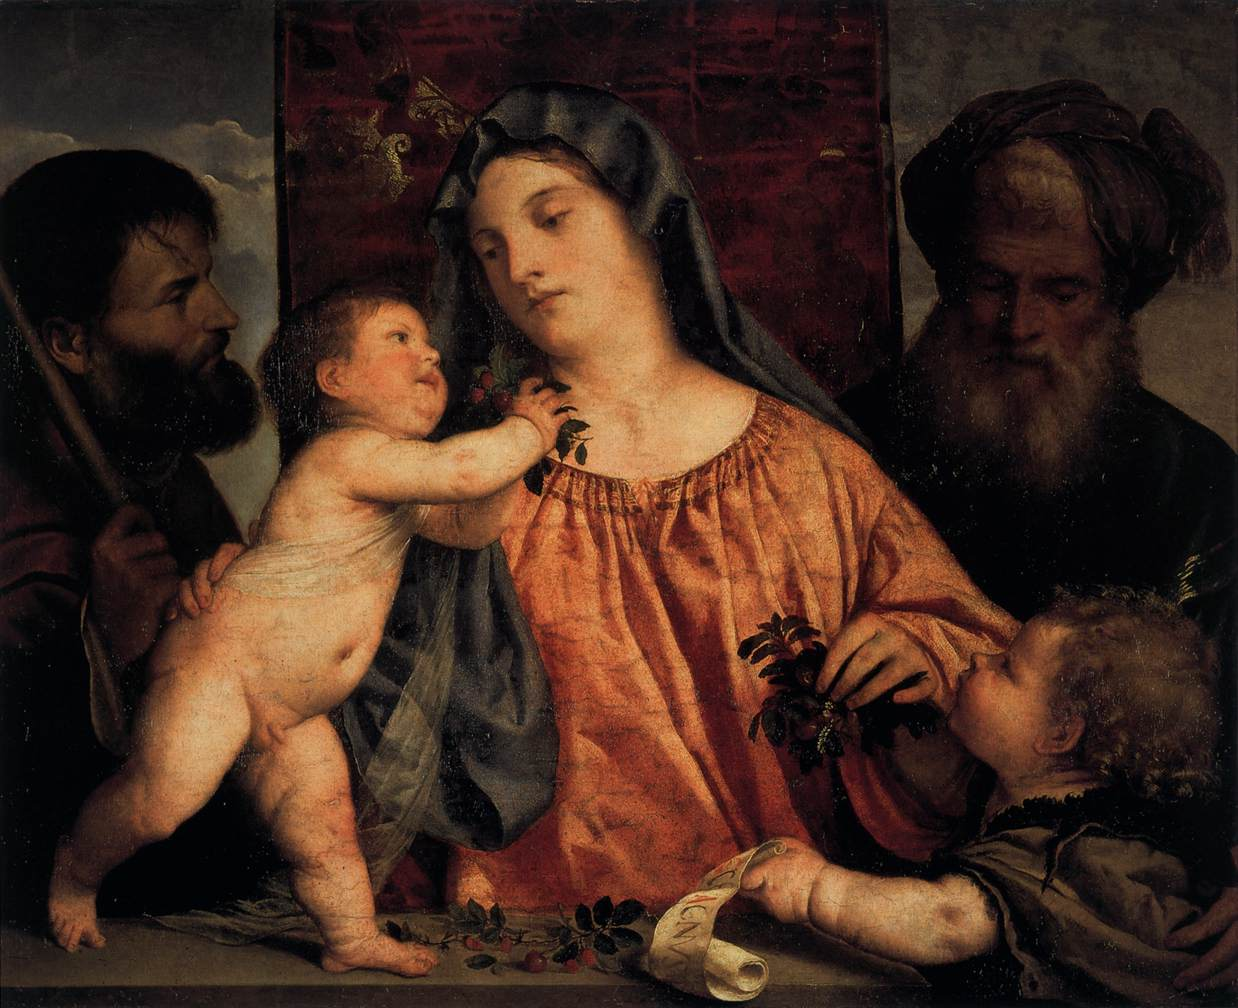Can you speak about the symbolism present in the items held or worn by the figures? Certainly! In the painting, symbolism pervades the depicted items imbuing the scene with layers of meaning. Mary often wears blue, symbolizing her purity and her role as the Queen of Heaven. The infant Jesus's nudity represents his human vulnerability and incarnation. John the Baptist's reed cross prefigures Christ’s crucifixion, while the berries he offers hint at the future 'fruit of salvation' Jesus will bring. Joseph’s staff and the elderly figure's contemplative gaze perhaps allude to wisdom and guidance, anchoring the scene in themes of divine providence and foresight. 